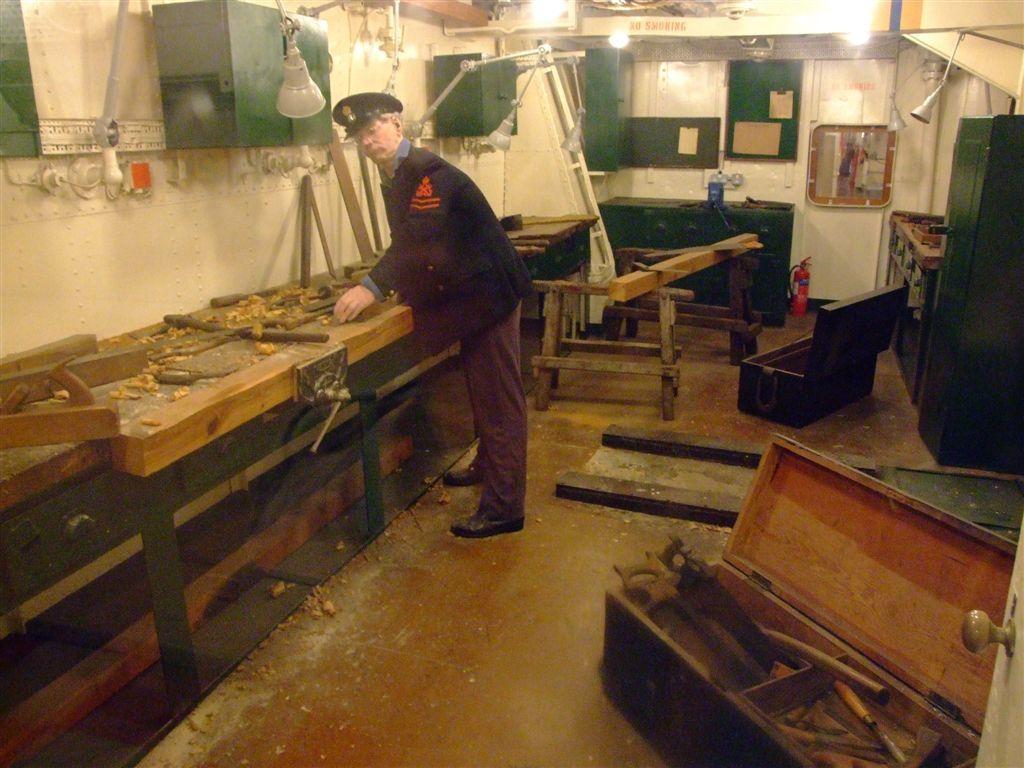Please provide a concise description of this image. The man in the middle of the picture wearing a black blazer and black cap is cutting wood. Behind him, we see a table. Beside him, we see a wall in white color and a green color cupboard. At the bottom of the picture, we see a box containing cutting equipment. In the background, we see a cupboard in green color and a white wall. At the top of the picture, we see the bulbs. 